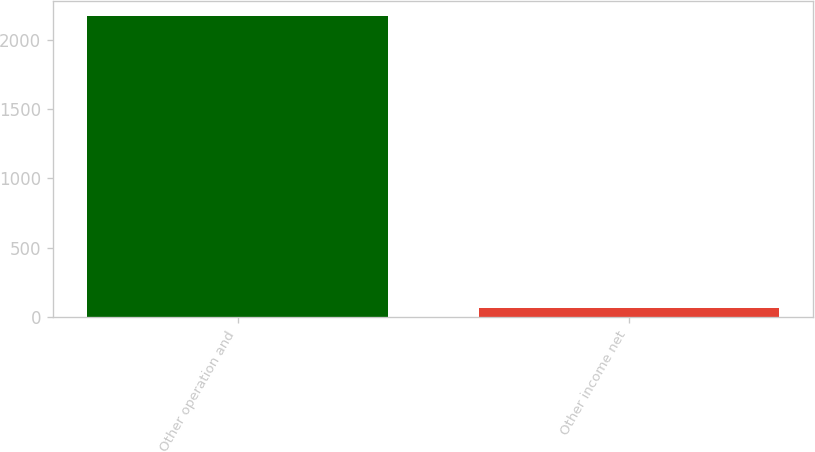Convert chart. <chart><loc_0><loc_0><loc_500><loc_500><bar_chart><fcel>Other operation and<fcel>Other income net<nl><fcel>2171.3<fcel>66.6<nl></chart> 